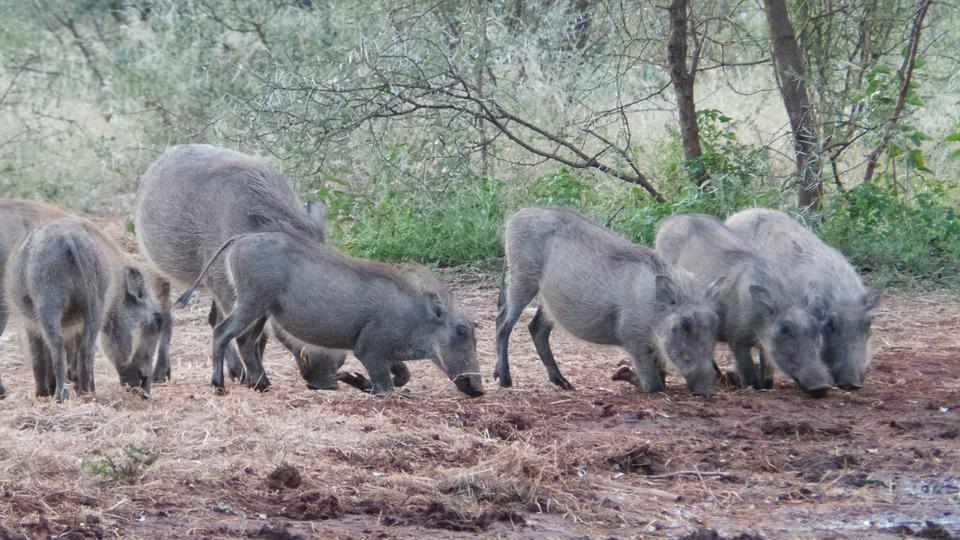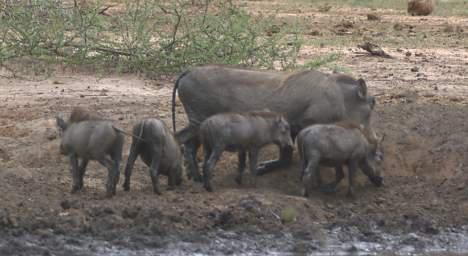The first image is the image on the left, the second image is the image on the right. Analyze the images presented: Is the assertion "One of the images contains exactly four warthogs." valid? Answer yes or no. No. The first image is the image on the left, the second image is the image on the right. Given the left and right images, does the statement "The image on the right has four or fewer warthogs." hold true? Answer yes or no. No. 